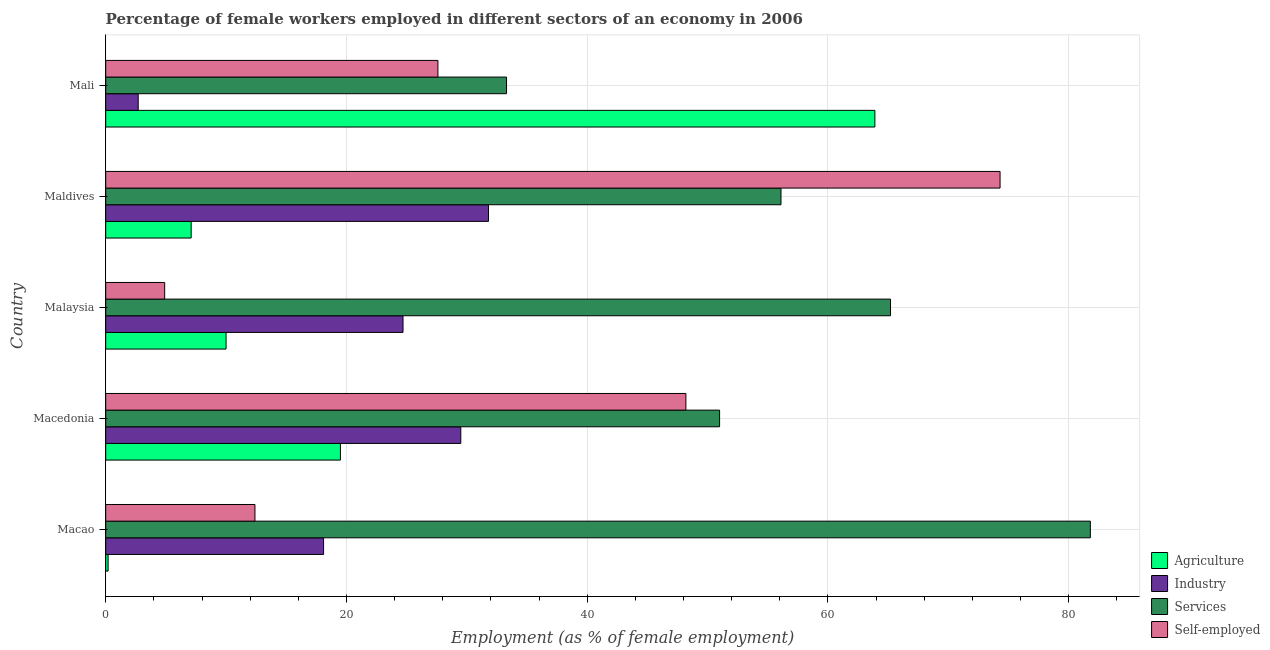How many different coloured bars are there?
Your answer should be compact. 4. Are the number of bars per tick equal to the number of legend labels?
Your answer should be very brief. Yes. Are the number of bars on each tick of the Y-axis equal?
Your answer should be compact. Yes. What is the label of the 5th group of bars from the top?
Keep it short and to the point. Macao. In how many cases, is the number of bars for a given country not equal to the number of legend labels?
Offer a terse response. 0. What is the percentage of female workers in industry in Mali?
Provide a short and direct response. 2.7. Across all countries, what is the maximum percentage of self employed female workers?
Your response must be concise. 74.3. Across all countries, what is the minimum percentage of self employed female workers?
Provide a short and direct response. 4.9. In which country was the percentage of female workers in industry maximum?
Your answer should be compact. Maldives. In which country was the percentage of female workers in industry minimum?
Your answer should be compact. Mali. What is the total percentage of female workers in agriculture in the graph?
Offer a terse response. 100.7. What is the difference between the percentage of female workers in services in Maldives and that in Mali?
Offer a terse response. 22.8. What is the difference between the percentage of female workers in services in Mali and the percentage of self employed female workers in Malaysia?
Offer a very short reply. 28.4. What is the average percentage of self employed female workers per country?
Your answer should be very brief. 33.48. What is the difference between the percentage of female workers in industry and percentage of female workers in services in Macao?
Your answer should be very brief. -63.7. What is the ratio of the percentage of female workers in services in Malaysia to that in Mali?
Provide a succinct answer. 1.96. Is the difference between the percentage of self employed female workers in Macao and Macedonia greater than the difference between the percentage of female workers in industry in Macao and Macedonia?
Make the answer very short. No. What is the difference between the highest and the second highest percentage of female workers in agriculture?
Your answer should be very brief. 44.4. What is the difference between the highest and the lowest percentage of self employed female workers?
Give a very brief answer. 69.4. In how many countries, is the percentage of female workers in services greater than the average percentage of female workers in services taken over all countries?
Provide a short and direct response. 2. Is the sum of the percentage of self employed female workers in Maldives and Mali greater than the maximum percentage of female workers in agriculture across all countries?
Give a very brief answer. Yes. Is it the case that in every country, the sum of the percentage of female workers in services and percentage of female workers in industry is greater than the sum of percentage of self employed female workers and percentage of female workers in agriculture?
Make the answer very short. No. What does the 4th bar from the top in Maldives represents?
Provide a short and direct response. Agriculture. What does the 1st bar from the bottom in Malaysia represents?
Keep it short and to the point. Agriculture. Is it the case that in every country, the sum of the percentage of female workers in agriculture and percentage of female workers in industry is greater than the percentage of female workers in services?
Provide a short and direct response. No. How many bars are there?
Your answer should be very brief. 20. Are the values on the major ticks of X-axis written in scientific E-notation?
Provide a short and direct response. No. Does the graph contain any zero values?
Ensure brevity in your answer.  No. How many legend labels are there?
Your answer should be very brief. 4. How are the legend labels stacked?
Keep it short and to the point. Vertical. What is the title of the graph?
Offer a terse response. Percentage of female workers employed in different sectors of an economy in 2006. What is the label or title of the X-axis?
Make the answer very short. Employment (as % of female employment). What is the Employment (as % of female employment) of Agriculture in Macao?
Keep it short and to the point. 0.2. What is the Employment (as % of female employment) in Industry in Macao?
Make the answer very short. 18.1. What is the Employment (as % of female employment) in Services in Macao?
Give a very brief answer. 81.8. What is the Employment (as % of female employment) in Self-employed in Macao?
Your response must be concise. 12.4. What is the Employment (as % of female employment) of Agriculture in Macedonia?
Your answer should be very brief. 19.5. What is the Employment (as % of female employment) of Industry in Macedonia?
Offer a terse response. 29.5. What is the Employment (as % of female employment) in Self-employed in Macedonia?
Offer a very short reply. 48.2. What is the Employment (as % of female employment) in Industry in Malaysia?
Your response must be concise. 24.7. What is the Employment (as % of female employment) of Services in Malaysia?
Your response must be concise. 65.2. What is the Employment (as % of female employment) in Self-employed in Malaysia?
Ensure brevity in your answer.  4.9. What is the Employment (as % of female employment) of Agriculture in Maldives?
Provide a short and direct response. 7.1. What is the Employment (as % of female employment) in Industry in Maldives?
Your response must be concise. 31.8. What is the Employment (as % of female employment) of Services in Maldives?
Offer a terse response. 56.1. What is the Employment (as % of female employment) in Self-employed in Maldives?
Your answer should be compact. 74.3. What is the Employment (as % of female employment) in Agriculture in Mali?
Provide a short and direct response. 63.9. What is the Employment (as % of female employment) of Industry in Mali?
Your response must be concise. 2.7. What is the Employment (as % of female employment) in Services in Mali?
Your response must be concise. 33.3. What is the Employment (as % of female employment) in Self-employed in Mali?
Offer a terse response. 27.6. Across all countries, what is the maximum Employment (as % of female employment) in Agriculture?
Provide a short and direct response. 63.9. Across all countries, what is the maximum Employment (as % of female employment) in Industry?
Your answer should be very brief. 31.8. Across all countries, what is the maximum Employment (as % of female employment) in Services?
Give a very brief answer. 81.8. Across all countries, what is the maximum Employment (as % of female employment) of Self-employed?
Ensure brevity in your answer.  74.3. Across all countries, what is the minimum Employment (as % of female employment) in Agriculture?
Ensure brevity in your answer.  0.2. Across all countries, what is the minimum Employment (as % of female employment) in Industry?
Keep it short and to the point. 2.7. Across all countries, what is the minimum Employment (as % of female employment) of Services?
Give a very brief answer. 33.3. Across all countries, what is the minimum Employment (as % of female employment) of Self-employed?
Keep it short and to the point. 4.9. What is the total Employment (as % of female employment) in Agriculture in the graph?
Provide a succinct answer. 100.7. What is the total Employment (as % of female employment) of Industry in the graph?
Provide a short and direct response. 106.8. What is the total Employment (as % of female employment) in Services in the graph?
Keep it short and to the point. 287.4. What is the total Employment (as % of female employment) of Self-employed in the graph?
Your answer should be compact. 167.4. What is the difference between the Employment (as % of female employment) in Agriculture in Macao and that in Macedonia?
Provide a short and direct response. -19.3. What is the difference between the Employment (as % of female employment) of Services in Macao and that in Macedonia?
Keep it short and to the point. 30.8. What is the difference between the Employment (as % of female employment) in Self-employed in Macao and that in Macedonia?
Your response must be concise. -35.8. What is the difference between the Employment (as % of female employment) of Agriculture in Macao and that in Malaysia?
Ensure brevity in your answer.  -9.8. What is the difference between the Employment (as % of female employment) in Services in Macao and that in Malaysia?
Provide a short and direct response. 16.6. What is the difference between the Employment (as % of female employment) in Industry in Macao and that in Maldives?
Give a very brief answer. -13.7. What is the difference between the Employment (as % of female employment) in Services in Macao and that in Maldives?
Keep it short and to the point. 25.7. What is the difference between the Employment (as % of female employment) of Self-employed in Macao and that in Maldives?
Keep it short and to the point. -61.9. What is the difference between the Employment (as % of female employment) in Agriculture in Macao and that in Mali?
Give a very brief answer. -63.7. What is the difference between the Employment (as % of female employment) of Industry in Macao and that in Mali?
Make the answer very short. 15.4. What is the difference between the Employment (as % of female employment) in Services in Macao and that in Mali?
Offer a terse response. 48.5. What is the difference between the Employment (as % of female employment) in Self-employed in Macao and that in Mali?
Provide a short and direct response. -15.2. What is the difference between the Employment (as % of female employment) of Agriculture in Macedonia and that in Malaysia?
Provide a short and direct response. 9.5. What is the difference between the Employment (as % of female employment) in Industry in Macedonia and that in Malaysia?
Offer a very short reply. 4.8. What is the difference between the Employment (as % of female employment) of Services in Macedonia and that in Malaysia?
Offer a terse response. -14.2. What is the difference between the Employment (as % of female employment) in Self-employed in Macedonia and that in Malaysia?
Give a very brief answer. 43.3. What is the difference between the Employment (as % of female employment) of Agriculture in Macedonia and that in Maldives?
Offer a very short reply. 12.4. What is the difference between the Employment (as % of female employment) of Industry in Macedonia and that in Maldives?
Keep it short and to the point. -2.3. What is the difference between the Employment (as % of female employment) in Services in Macedonia and that in Maldives?
Offer a terse response. -5.1. What is the difference between the Employment (as % of female employment) in Self-employed in Macedonia and that in Maldives?
Ensure brevity in your answer.  -26.1. What is the difference between the Employment (as % of female employment) of Agriculture in Macedonia and that in Mali?
Your response must be concise. -44.4. What is the difference between the Employment (as % of female employment) of Industry in Macedonia and that in Mali?
Keep it short and to the point. 26.8. What is the difference between the Employment (as % of female employment) in Self-employed in Macedonia and that in Mali?
Ensure brevity in your answer.  20.6. What is the difference between the Employment (as % of female employment) of Agriculture in Malaysia and that in Maldives?
Your answer should be very brief. 2.9. What is the difference between the Employment (as % of female employment) of Industry in Malaysia and that in Maldives?
Ensure brevity in your answer.  -7.1. What is the difference between the Employment (as % of female employment) of Services in Malaysia and that in Maldives?
Keep it short and to the point. 9.1. What is the difference between the Employment (as % of female employment) of Self-employed in Malaysia and that in Maldives?
Give a very brief answer. -69.4. What is the difference between the Employment (as % of female employment) in Agriculture in Malaysia and that in Mali?
Keep it short and to the point. -53.9. What is the difference between the Employment (as % of female employment) in Services in Malaysia and that in Mali?
Your answer should be very brief. 31.9. What is the difference between the Employment (as % of female employment) in Self-employed in Malaysia and that in Mali?
Give a very brief answer. -22.7. What is the difference between the Employment (as % of female employment) in Agriculture in Maldives and that in Mali?
Make the answer very short. -56.8. What is the difference between the Employment (as % of female employment) of Industry in Maldives and that in Mali?
Your answer should be compact. 29.1. What is the difference between the Employment (as % of female employment) in Services in Maldives and that in Mali?
Provide a short and direct response. 22.8. What is the difference between the Employment (as % of female employment) of Self-employed in Maldives and that in Mali?
Provide a short and direct response. 46.7. What is the difference between the Employment (as % of female employment) in Agriculture in Macao and the Employment (as % of female employment) in Industry in Macedonia?
Your answer should be compact. -29.3. What is the difference between the Employment (as % of female employment) in Agriculture in Macao and the Employment (as % of female employment) in Services in Macedonia?
Keep it short and to the point. -50.8. What is the difference between the Employment (as % of female employment) of Agriculture in Macao and the Employment (as % of female employment) of Self-employed in Macedonia?
Offer a terse response. -48. What is the difference between the Employment (as % of female employment) of Industry in Macao and the Employment (as % of female employment) of Services in Macedonia?
Ensure brevity in your answer.  -32.9. What is the difference between the Employment (as % of female employment) in Industry in Macao and the Employment (as % of female employment) in Self-employed in Macedonia?
Your response must be concise. -30.1. What is the difference between the Employment (as % of female employment) of Services in Macao and the Employment (as % of female employment) of Self-employed in Macedonia?
Offer a very short reply. 33.6. What is the difference between the Employment (as % of female employment) in Agriculture in Macao and the Employment (as % of female employment) in Industry in Malaysia?
Your response must be concise. -24.5. What is the difference between the Employment (as % of female employment) of Agriculture in Macao and the Employment (as % of female employment) of Services in Malaysia?
Offer a terse response. -65. What is the difference between the Employment (as % of female employment) of Agriculture in Macao and the Employment (as % of female employment) of Self-employed in Malaysia?
Your response must be concise. -4.7. What is the difference between the Employment (as % of female employment) of Industry in Macao and the Employment (as % of female employment) of Services in Malaysia?
Offer a terse response. -47.1. What is the difference between the Employment (as % of female employment) of Services in Macao and the Employment (as % of female employment) of Self-employed in Malaysia?
Your response must be concise. 76.9. What is the difference between the Employment (as % of female employment) in Agriculture in Macao and the Employment (as % of female employment) in Industry in Maldives?
Make the answer very short. -31.6. What is the difference between the Employment (as % of female employment) in Agriculture in Macao and the Employment (as % of female employment) in Services in Maldives?
Offer a very short reply. -55.9. What is the difference between the Employment (as % of female employment) of Agriculture in Macao and the Employment (as % of female employment) of Self-employed in Maldives?
Give a very brief answer. -74.1. What is the difference between the Employment (as % of female employment) of Industry in Macao and the Employment (as % of female employment) of Services in Maldives?
Make the answer very short. -38. What is the difference between the Employment (as % of female employment) in Industry in Macao and the Employment (as % of female employment) in Self-employed in Maldives?
Provide a short and direct response. -56.2. What is the difference between the Employment (as % of female employment) of Services in Macao and the Employment (as % of female employment) of Self-employed in Maldives?
Offer a very short reply. 7.5. What is the difference between the Employment (as % of female employment) of Agriculture in Macao and the Employment (as % of female employment) of Industry in Mali?
Your answer should be compact. -2.5. What is the difference between the Employment (as % of female employment) of Agriculture in Macao and the Employment (as % of female employment) of Services in Mali?
Your response must be concise. -33.1. What is the difference between the Employment (as % of female employment) in Agriculture in Macao and the Employment (as % of female employment) in Self-employed in Mali?
Provide a succinct answer. -27.4. What is the difference between the Employment (as % of female employment) of Industry in Macao and the Employment (as % of female employment) of Services in Mali?
Ensure brevity in your answer.  -15.2. What is the difference between the Employment (as % of female employment) of Industry in Macao and the Employment (as % of female employment) of Self-employed in Mali?
Your answer should be very brief. -9.5. What is the difference between the Employment (as % of female employment) of Services in Macao and the Employment (as % of female employment) of Self-employed in Mali?
Provide a short and direct response. 54.2. What is the difference between the Employment (as % of female employment) of Agriculture in Macedonia and the Employment (as % of female employment) of Industry in Malaysia?
Your response must be concise. -5.2. What is the difference between the Employment (as % of female employment) in Agriculture in Macedonia and the Employment (as % of female employment) in Services in Malaysia?
Your answer should be compact. -45.7. What is the difference between the Employment (as % of female employment) of Industry in Macedonia and the Employment (as % of female employment) of Services in Malaysia?
Provide a succinct answer. -35.7. What is the difference between the Employment (as % of female employment) of Industry in Macedonia and the Employment (as % of female employment) of Self-employed in Malaysia?
Offer a very short reply. 24.6. What is the difference between the Employment (as % of female employment) of Services in Macedonia and the Employment (as % of female employment) of Self-employed in Malaysia?
Your answer should be compact. 46.1. What is the difference between the Employment (as % of female employment) of Agriculture in Macedonia and the Employment (as % of female employment) of Services in Maldives?
Give a very brief answer. -36.6. What is the difference between the Employment (as % of female employment) in Agriculture in Macedonia and the Employment (as % of female employment) in Self-employed in Maldives?
Ensure brevity in your answer.  -54.8. What is the difference between the Employment (as % of female employment) in Industry in Macedonia and the Employment (as % of female employment) in Services in Maldives?
Offer a terse response. -26.6. What is the difference between the Employment (as % of female employment) in Industry in Macedonia and the Employment (as % of female employment) in Self-employed in Maldives?
Offer a terse response. -44.8. What is the difference between the Employment (as % of female employment) in Services in Macedonia and the Employment (as % of female employment) in Self-employed in Maldives?
Make the answer very short. -23.3. What is the difference between the Employment (as % of female employment) in Agriculture in Macedonia and the Employment (as % of female employment) in Services in Mali?
Offer a very short reply. -13.8. What is the difference between the Employment (as % of female employment) in Agriculture in Macedonia and the Employment (as % of female employment) in Self-employed in Mali?
Make the answer very short. -8.1. What is the difference between the Employment (as % of female employment) of Industry in Macedonia and the Employment (as % of female employment) of Services in Mali?
Ensure brevity in your answer.  -3.8. What is the difference between the Employment (as % of female employment) in Industry in Macedonia and the Employment (as % of female employment) in Self-employed in Mali?
Give a very brief answer. 1.9. What is the difference between the Employment (as % of female employment) of Services in Macedonia and the Employment (as % of female employment) of Self-employed in Mali?
Provide a short and direct response. 23.4. What is the difference between the Employment (as % of female employment) of Agriculture in Malaysia and the Employment (as % of female employment) of Industry in Maldives?
Offer a terse response. -21.8. What is the difference between the Employment (as % of female employment) of Agriculture in Malaysia and the Employment (as % of female employment) of Services in Maldives?
Your answer should be very brief. -46.1. What is the difference between the Employment (as % of female employment) in Agriculture in Malaysia and the Employment (as % of female employment) in Self-employed in Maldives?
Offer a very short reply. -64.3. What is the difference between the Employment (as % of female employment) in Industry in Malaysia and the Employment (as % of female employment) in Services in Maldives?
Provide a short and direct response. -31.4. What is the difference between the Employment (as % of female employment) of Industry in Malaysia and the Employment (as % of female employment) of Self-employed in Maldives?
Offer a terse response. -49.6. What is the difference between the Employment (as % of female employment) of Agriculture in Malaysia and the Employment (as % of female employment) of Industry in Mali?
Your answer should be very brief. 7.3. What is the difference between the Employment (as % of female employment) of Agriculture in Malaysia and the Employment (as % of female employment) of Services in Mali?
Your answer should be very brief. -23.3. What is the difference between the Employment (as % of female employment) of Agriculture in Malaysia and the Employment (as % of female employment) of Self-employed in Mali?
Your answer should be very brief. -17.6. What is the difference between the Employment (as % of female employment) of Industry in Malaysia and the Employment (as % of female employment) of Services in Mali?
Ensure brevity in your answer.  -8.6. What is the difference between the Employment (as % of female employment) of Industry in Malaysia and the Employment (as % of female employment) of Self-employed in Mali?
Make the answer very short. -2.9. What is the difference between the Employment (as % of female employment) of Services in Malaysia and the Employment (as % of female employment) of Self-employed in Mali?
Your response must be concise. 37.6. What is the difference between the Employment (as % of female employment) in Agriculture in Maldives and the Employment (as % of female employment) in Industry in Mali?
Provide a succinct answer. 4.4. What is the difference between the Employment (as % of female employment) of Agriculture in Maldives and the Employment (as % of female employment) of Services in Mali?
Your answer should be very brief. -26.2. What is the difference between the Employment (as % of female employment) of Agriculture in Maldives and the Employment (as % of female employment) of Self-employed in Mali?
Make the answer very short. -20.5. What is the difference between the Employment (as % of female employment) of Industry in Maldives and the Employment (as % of female employment) of Services in Mali?
Provide a short and direct response. -1.5. What is the difference between the Employment (as % of female employment) of Services in Maldives and the Employment (as % of female employment) of Self-employed in Mali?
Your answer should be very brief. 28.5. What is the average Employment (as % of female employment) of Agriculture per country?
Provide a succinct answer. 20.14. What is the average Employment (as % of female employment) in Industry per country?
Your answer should be very brief. 21.36. What is the average Employment (as % of female employment) of Services per country?
Keep it short and to the point. 57.48. What is the average Employment (as % of female employment) of Self-employed per country?
Give a very brief answer. 33.48. What is the difference between the Employment (as % of female employment) in Agriculture and Employment (as % of female employment) in Industry in Macao?
Make the answer very short. -17.9. What is the difference between the Employment (as % of female employment) of Agriculture and Employment (as % of female employment) of Services in Macao?
Offer a very short reply. -81.6. What is the difference between the Employment (as % of female employment) in Agriculture and Employment (as % of female employment) in Self-employed in Macao?
Give a very brief answer. -12.2. What is the difference between the Employment (as % of female employment) in Industry and Employment (as % of female employment) in Services in Macao?
Provide a short and direct response. -63.7. What is the difference between the Employment (as % of female employment) in Industry and Employment (as % of female employment) in Self-employed in Macao?
Provide a succinct answer. 5.7. What is the difference between the Employment (as % of female employment) of Services and Employment (as % of female employment) of Self-employed in Macao?
Your response must be concise. 69.4. What is the difference between the Employment (as % of female employment) of Agriculture and Employment (as % of female employment) of Services in Macedonia?
Make the answer very short. -31.5. What is the difference between the Employment (as % of female employment) of Agriculture and Employment (as % of female employment) of Self-employed in Macedonia?
Ensure brevity in your answer.  -28.7. What is the difference between the Employment (as % of female employment) in Industry and Employment (as % of female employment) in Services in Macedonia?
Your answer should be compact. -21.5. What is the difference between the Employment (as % of female employment) of Industry and Employment (as % of female employment) of Self-employed in Macedonia?
Keep it short and to the point. -18.7. What is the difference between the Employment (as % of female employment) in Services and Employment (as % of female employment) in Self-employed in Macedonia?
Provide a succinct answer. 2.8. What is the difference between the Employment (as % of female employment) of Agriculture and Employment (as % of female employment) of Industry in Malaysia?
Keep it short and to the point. -14.7. What is the difference between the Employment (as % of female employment) of Agriculture and Employment (as % of female employment) of Services in Malaysia?
Your response must be concise. -55.2. What is the difference between the Employment (as % of female employment) of Industry and Employment (as % of female employment) of Services in Malaysia?
Give a very brief answer. -40.5. What is the difference between the Employment (as % of female employment) in Industry and Employment (as % of female employment) in Self-employed in Malaysia?
Your answer should be compact. 19.8. What is the difference between the Employment (as % of female employment) of Services and Employment (as % of female employment) of Self-employed in Malaysia?
Keep it short and to the point. 60.3. What is the difference between the Employment (as % of female employment) of Agriculture and Employment (as % of female employment) of Industry in Maldives?
Offer a very short reply. -24.7. What is the difference between the Employment (as % of female employment) in Agriculture and Employment (as % of female employment) in Services in Maldives?
Ensure brevity in your answer.  -49. What is the difference between the Employment (as % of female employment) in Agriculture and Employment (as % of female employment) in Self-employed in Maldives?
Make the answer very short. -67.2. What is the difference between the Employment (as % of female employment) of Industry and Employment (as % of female employment) of Services in Maldives?
Give a very brief answer. -24.3. What is the difference between the Employment (as % of female employment) of Industry and Employment (as % of female employment) of Self-employed in Maldives?
Provide a succinct answer. -42.5. What is the difference between the Employment (as % of female employment) of Services and Employment (as % of female employment) of Self-employed in Maldives?
Offer a very short reply. -18.2. What is the difference between the Employment (as % of female employment) of Agriculture and Employment (as % of female employment) of Industry in Mali?
Ensure brevity in your answer.  61.2. What is the difference between the Employment (as % of female employment) of Agriculture and Employment (as % of female employment) of Services in Mali?
Offer a very short reply. 30.6. What is the difference between the Employment (as % of female employment) of Agriculture and Employment (as % of female employment) of Self-employed in Mali?
Offer a very short reply. 36.3. What is the difference between the Employment (as % of female employment) of Industry and Employment (as % of female employment) of Services in Mali?
Make the answer very short. -30.6. What is the difference between the Employment (as % of female employment) in Industry and Employment (as % of female employment) in Self-employed in Mali?
Your answer should be compact. -24.9. What is the difference between the Employment (as % of female employment) of Services and Employment (as % of female employment) of Self-employed in Mali?
Your answer should be very brief. 5.7. What is the ratio of the Employment (as % of female employment) in Agriculture in Macao to that in Macedonia?
Your answer should be very brief. 0.01. What is the ratio of the Employment (as % of female employment) of Industry in Macao to that in Macedonia?
Provide a short and direct response. 0.61. What is the ratio of the Employment (as % of female employment) in Services in Macao to that in Macedonia?
Provide a succinct answer. 1.6. What is the ratio of the Employment (as % of female employment) in Self-employed in Macao to that in Macedonia?
Keep it short and to the point. 0.26. What is the ratio of the Employment (as % of female employment) in Industry in Macao to that in Malaysia?
Give a very brief answer. 0.73. What is the ratio of the Employment (as % of female employment) of Services in Macao to that in Malaysia?
Keep it short and to the point. 1.25. What is the ratio of the Employment (as % of female employment) of Self-employed in Macao to that in Malaysia?
Your response must be concise. 2.53. What is the ratio of the Employment (as % of female employment) of Agriculture in Macao to that in Maldives?
Give a very brief answer. 0.03. What is the ratio of the Employment (as % of female employment) of Industry in Macao to that in Maldives?
Keep it short and to the point. 0.57. What is the ratio of the Employment (as % of female employment) in Services in Macao to that in Maldives?
Give a very brief answer. 1.46. What is the ratio of the Employment (as % of female employment) of Self-employed in Macao to that in Maldives?
Make the answer very short. 0.17. What is the ratio of the Employment (as % of female employment) in Agriculture in Macao to that in Mali?
Offer a very short reply. 0. What is the ratio of the Employment (as % of female employment) of Industry in Macao to that in Mali?
Your response must be concise. 6.7. What is the ratio of the Employment (as % of female employment) of Services in Macao to that in Mali?
Your response must be concise. 2.46. What is the ratio of the Employment (as % of female employment) of Self-employed in Macao to that in Mali?
Your response must be concise. 0.45. What is the ratio of the Employment (as % of female employment) of Agriculture in Macedonia to that in Malaysia?
Offer a very short reply. 1.95. What is the ratio of the Employment (as % of female employment) in Industry in Macedonia to that in Malaysia?
Your response must be concise. 1.19. What is the ratio of the Employment (as % of female employment) in Services in Macedonia to that in Malaysia?
Offer a terse response. 0.78. What is the ratio of the Employment (as % of female employment) of Self-employed in Macedonia to that in Malaysia?
Provide a short and direct response. 9.84. What is the ratio of the Employment (as % of female employment) in Agriculture in Macedonia to that in Maldives?
Your response must be concise. 2.75. What is the ratio of the Employment (as % of female employment) in Industry in Macedonia to that in Maldives?
Give a very brief answer. 0.93. What is the ratio of the Employment (as % of female employment) of Services in Macedonia to that in Maldives?
Offer a very short reply. 0.91. What is the ratio of the Employment (as % of female employment) in Self-employed in Macedonia to that in Maldives?
Your response must be concise. 0.65. What is the ratio of the Employment (as % of female employment) of Agriculture in Macedonia to that in Mali?
Your answer should be compact. 0.31. What is the ratio of the Employment (as % of female employment) in Industry in Macedonia to that in Mali?
Keep it short and to the point. 10.93. What is the ratio of the Employment (as % of female employment) of Services in Macedonia to that in Mali?
Ensure brevity in your answer.  1.53. What is the ratio of the Employment (as % of female employment) in Self-employed in Macedonia to that in Mali?
Offer a terse response. 1.75. What is the ratio of the Employment (as % of female employment) in Agriculture in Malaysia to that in Maldives?
Offer a terse response. 1.41. What is the ratio of the Employment (as % of female employment) in Industry in Malaysia to that in Maldives?
Offer a very short reply. 0.78. What is the ratio of the Employment (as % of female employment) in Services in Malaysia to that in Maldives?
Offer a very short reply. 1.16. What is the ratio of the Employment (as % of female employment) of Self-employed in Malaysia to that in Maldives?
Make the answer very short. 0.07. What is the ratio of the Employment (as % of female employment) in Agriculture in Malaysia to that in Mali?
Provide a short and direct response. 0.16. What is the ratio of the Employment (as % of female employment) of Industry in Malaysia to that in Mali?
Ensure brevity in your answer.  9.15. What is the ratio of the Employment (as % of female employment) in Services in Malaysia to that in Mali?
Give a very brief answer. 1.96. What is the ratio of the Employment (as % of female employment) of Self-employed in Malaysia to that in Mali?
Give a very brief answer. 0.18. What is the ratio of the Employment (as % of female employment) in Industry in Maldives to that in Mali?
Your answer should be compact. 11.78. What is the ratio of the Employment (as % of female employment) of Services in Maldives to that in Mali?
Your response must be concise. 1.68. What is the ratio of the Employment (as % of female employment) of Self-employed in Maldives to that in Mali?
Provide a short and direct response. 2.69. What is the difference between the highest and the second highest Employment (as % of female employment) in Agriculture?
Make the answer very short. 44.4. What is the difference between the highest and the second highest Employment (as % of female employment) of Industry?
Keep it short and to the point. 2.3. What is the difference between the highest and the second highest Employment (as % of female employment) in Services?
Your answer should be compact. 16.6. What is the difference between the highest and the second highest Employment (as % of female employment) of Self-employed?
Provide a short and direct response. 26.1. What is the difference between the highest and the lowest Employment (as % of female employment) of Agriculture?
Give a very brief answer. 63.7. What is the difference between the highest and the lowest Employment (as % of female employment) in Industry?
Offer a very short reply. 29.1. What is the difference between the highest and the lowest Employment (as % of female employment) in Services?
Your answer should be very brief. 48.5. What is the difference between the highest and the lowest Employment (as % of female employment) of Self-employed?
Provide a succinct answer. 69.4. 